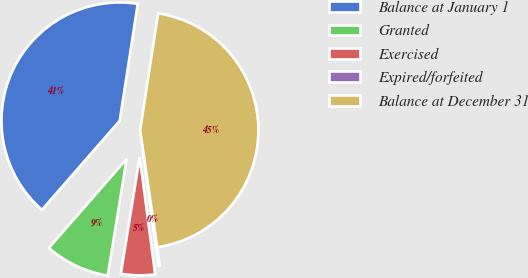Convert chart to OTSL. <chart><loc_0><loc_0><loc_500><loc_500><pie_chart><fcel>Balance at January 1<fcel>Granted<fcel>Exercised<fcel>Expired/forfeited<fcel>Balance at December 31<nl><fcel>41.01%<fcel>8.87%<fcel>4.64%<fcel>0.23%<fcel>45.25%<nl></chart> 